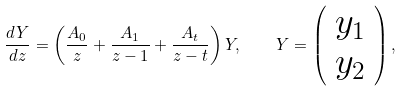Convert formula to latex. <formula><loc_0><loc_0><loc_500><loc_500>\frac { d Y } { d z } = \left ( \frac { A _ { 0 } } { z } + \frac { A _ { 1 } } { z - 1 } + \frac { A _ { t } } { z - t } \right ) Y , \quad Y = \left ( \begin{array} { l } y _ { 1 } \\ y _ { 2 } \end{array} \right ) ,</formula> 